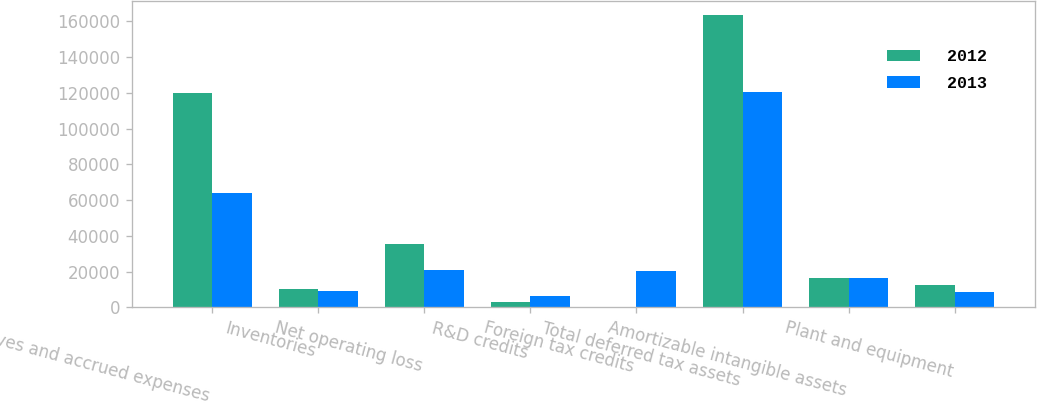Convert chart to OTSL. <chart><loc_0><loc_0><loc_500><loc_500><stacked_bar_chart><ecel><fcel>Reserves and accrued expenses<fcel>Inventories<fcel>Net operating loss<fcel>R&D credits<fcel>Foreign tax credits<fcel>Total deferred tax assets<fcel>Amortizable intangible assets<fcel>Plant and equipment<nl><fcel>2012<fcel>119955<fcel>10315<fcel>35286<fcel>3134<fcel>425<fcel>163198<fcel>16346.5<fcel>12423<nl><fcel>2013<fcel>63703<fcel>9171<fcel>21161<fcel>6331<fcel>20270<fcel>120636<fcel>16346.5<fcel>8844<nl></chart> 